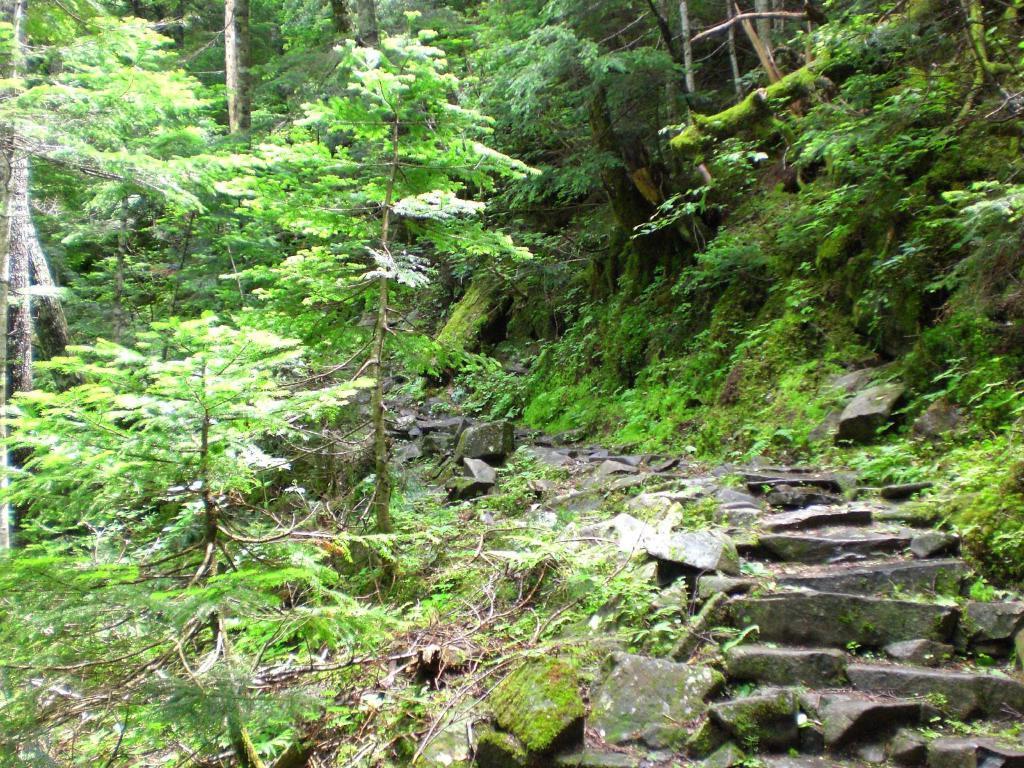Please provide a concise description of this image. In this picture we can observe a path. There are some rocks in this path. We can observe plants and trees in the background. 